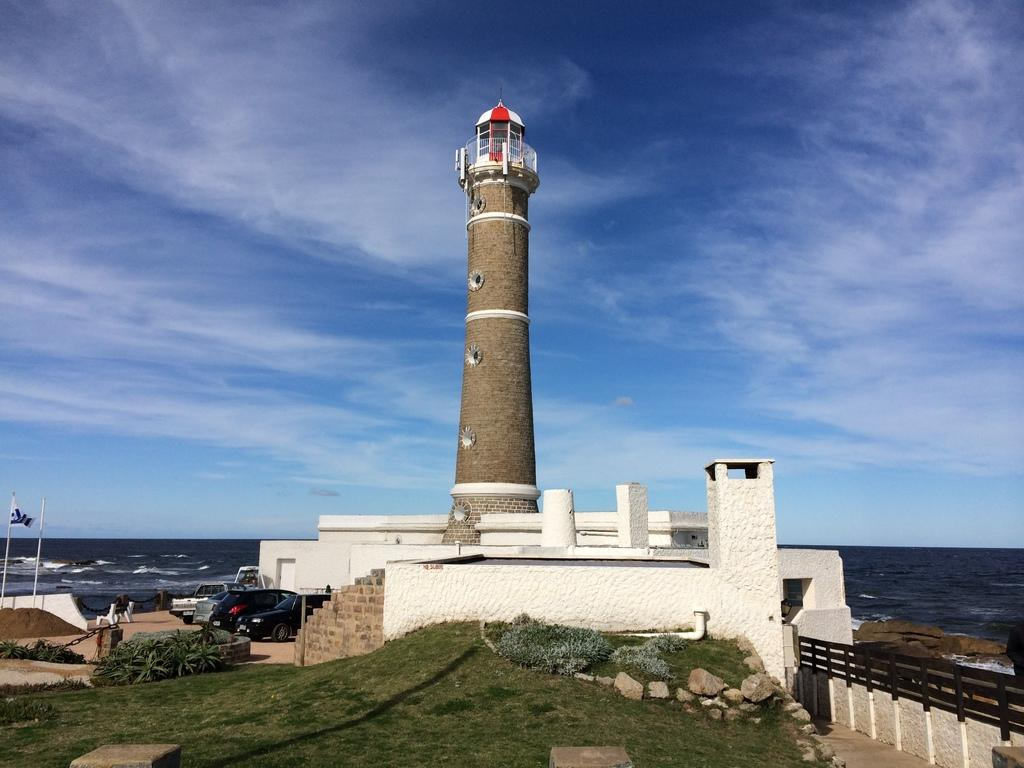What is the main structure in the image? There is a lighthouse in the image. What other objects are near the lighthouse? There are cars beside the lighthouse. What natural feature can be seen in the background of the image? There is a sea visible in the background of the image. What is the color of the sky in the background of the image? The sky is blue in the background of the image. Who is the owner of the lighthouse in the image? There is no information about the owner of the lighthouse in the image. How many birds can be seen flying near the lighthouse in the image? There are no birds visible in the image. 